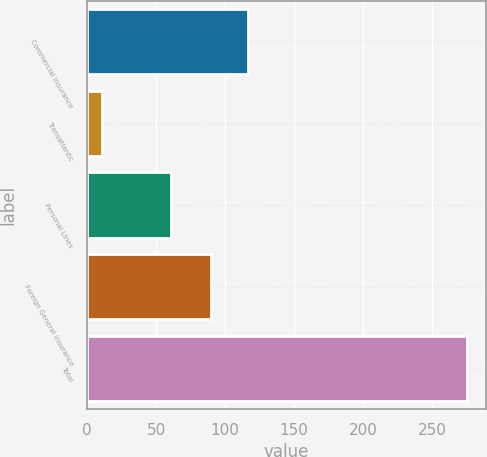Convert chart. <chart><loc_0><loc_0><loc_500><loc_500><bar_chart><fcel>Commercial Insurance<fcel>Transatlantic<fcel>Personal Lines<fcel>Foreign General Insurance<fcel>Total<nl><fcel>116.4<fcel>11<fcel>61<fcel>90<fcel>275<nl></chart> 